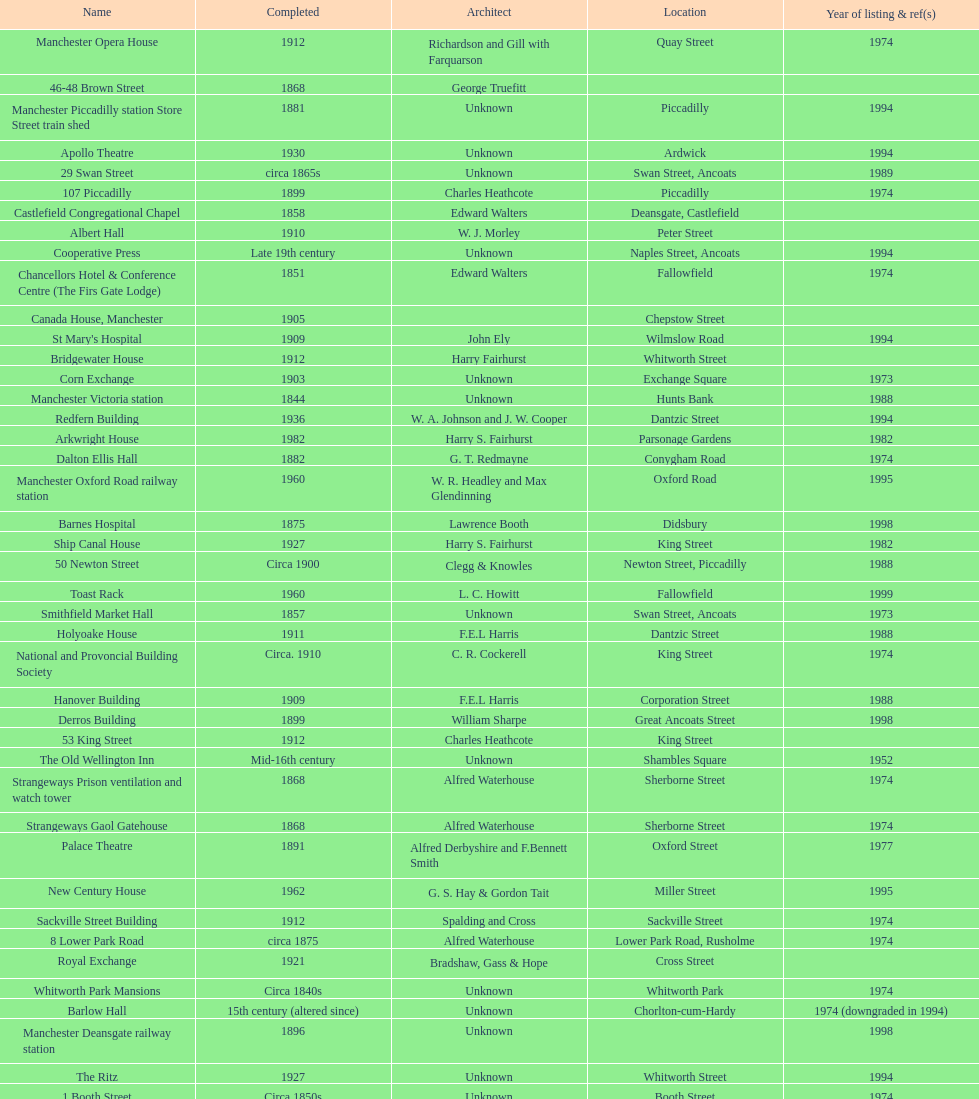How many buildings do not have an image listed? 11. 